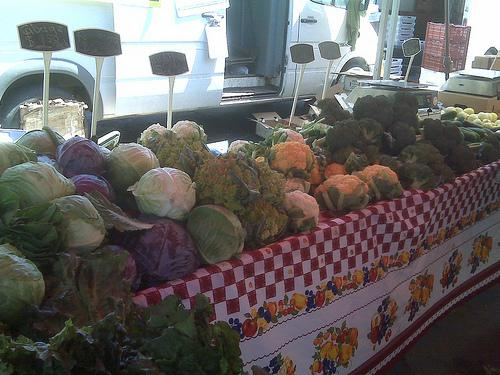Express your thoughts about the variety of items in the image. The image showcases a diverse collection of fresh vegetables, such as green and purple cabbage, cauliflower, broccoli, and cucumbers, which look healthy and appealing. Mention any unique objects in the image that catch your attention. There is a shirt hanging on the mirror, a box laying on the street, and a step on a truck which are interesting details in the image. Describe the vehicle that appears in the image and its purpose. A white delivery truck is present in the image, likely for transporting vegetables to the market. Find the object hanging from the mirror and its color. There is a green hanging towel hanging on the mirror. How would you describe the environment in which the image was taken? The image displays a street market setting with a table full of vegetables for sale, a white delivery van, and a stack of red crates nearby. What can you say about the pricing of items in the image? There is a black sign indicating a cabbage sale for $1.50, but other prices are not visible in the image. What is the color of the table cloth in the image? The table cloth is red and white checkered. Identify the main objects displayed on the table in the image. There are lettuce and cabbage, cauliflower, broccoli, cucumber, and other vegetables on the table. Describe the placement of the two silver scales and what they are used for. The two silver scales are placed on the table full of vegetables, and they are used for measuring the weight of the produce for sale. Summarize the main subject of the image and the items arranged in a row. The main subject of the image is a table with various vegetables, including cabbage, cauliflower, broccoli, cucumber, and other greens, displayed in a row for sale at a street market. 